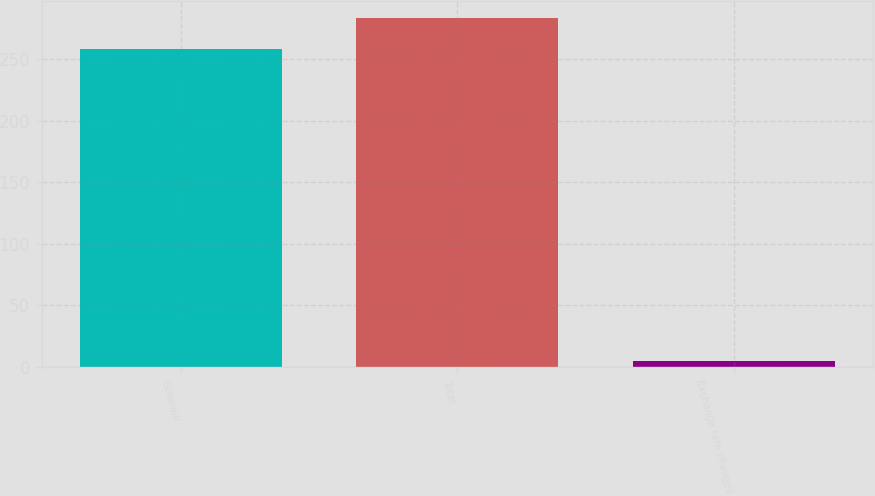<chart> <loc_0><loc_0><loc_500><loc_500><bar_chart><fcel>Goodwill<fcel>Total<fcel>Exchange rate changes<nl><fcel>258<fcel>283.3<fcel>5<nl></chart> 